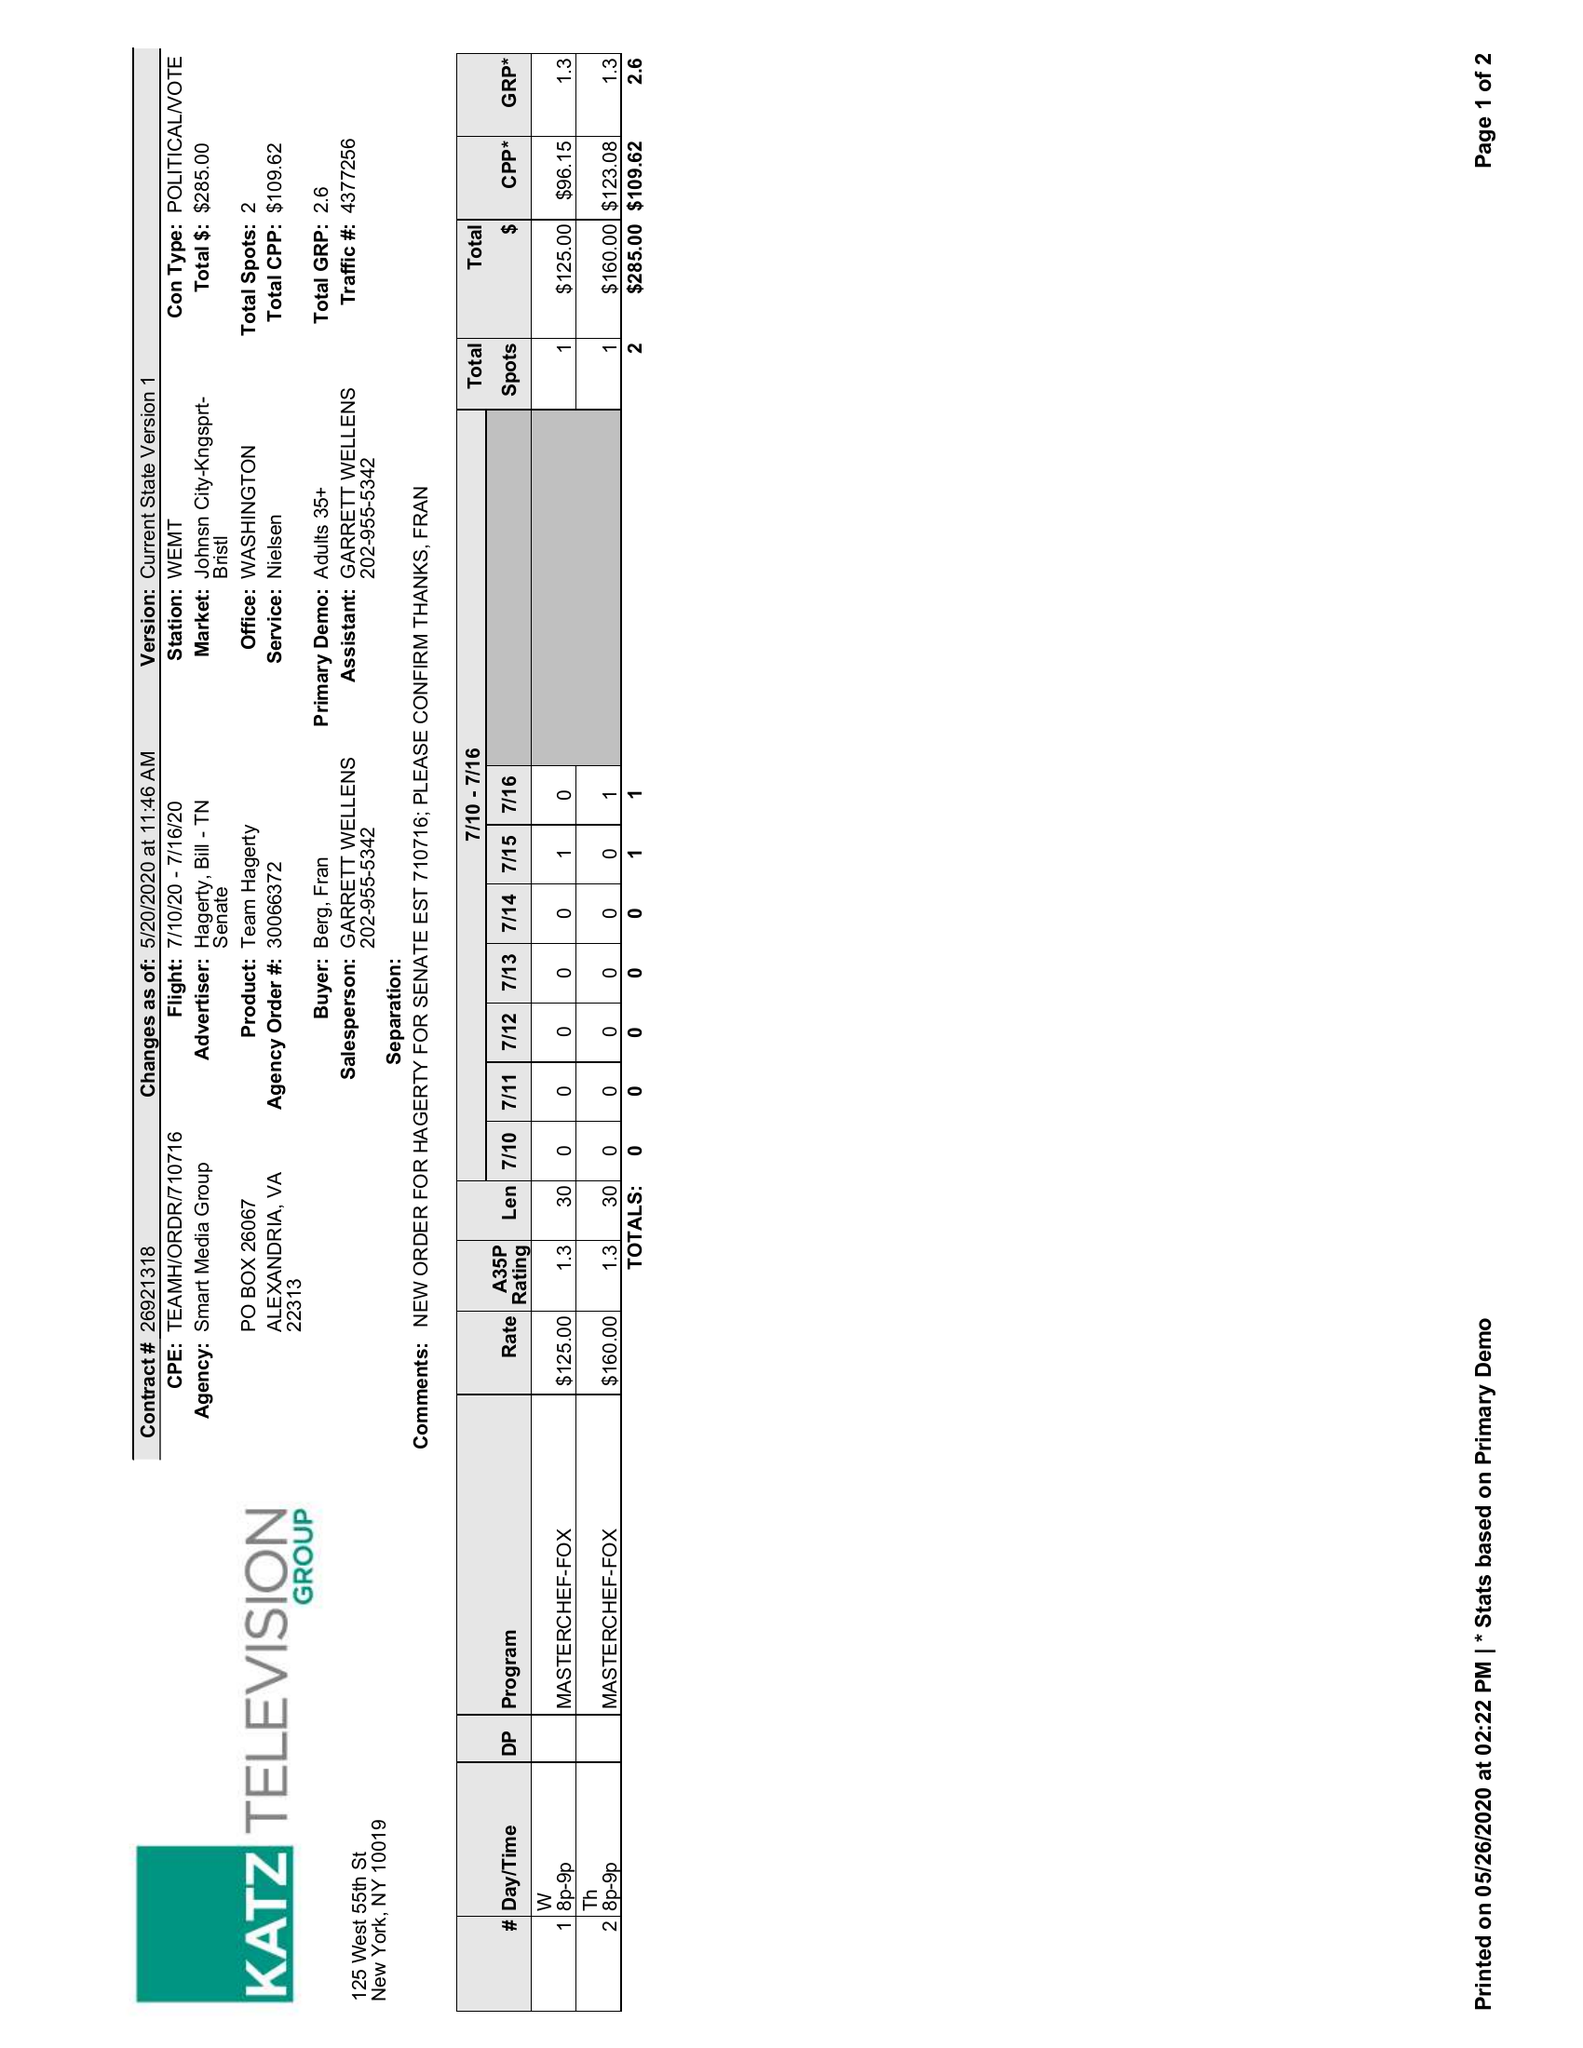What is the value for the flight_to?
Answer the question using a single word or phrase. 07/16/20 